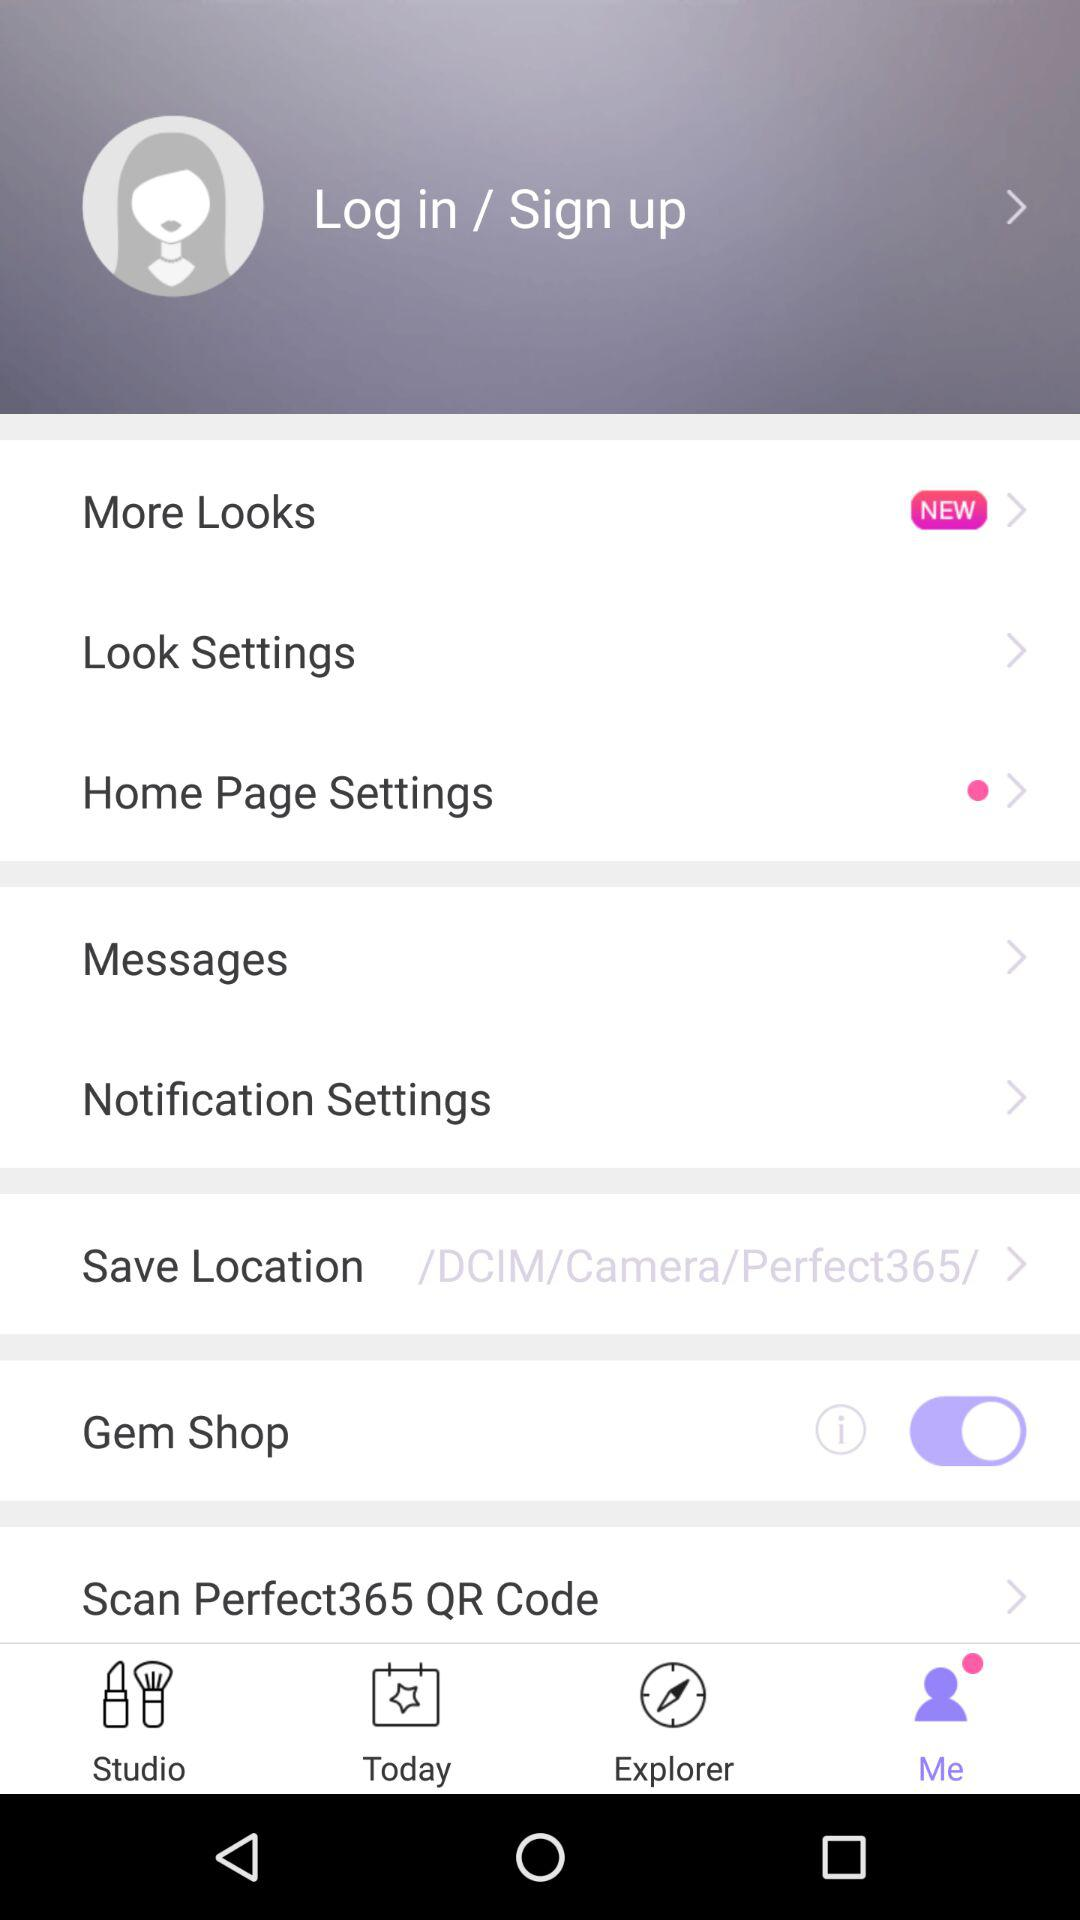What's the save location path? The save location path is "/DCIM/Camera/Perfect365/". 